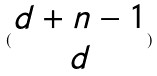<formula> <loc_0><loc_0><loc_500><loc_500>( \begin{matrix} d + n - 1 \\ d \end{matrix} )</formula> 